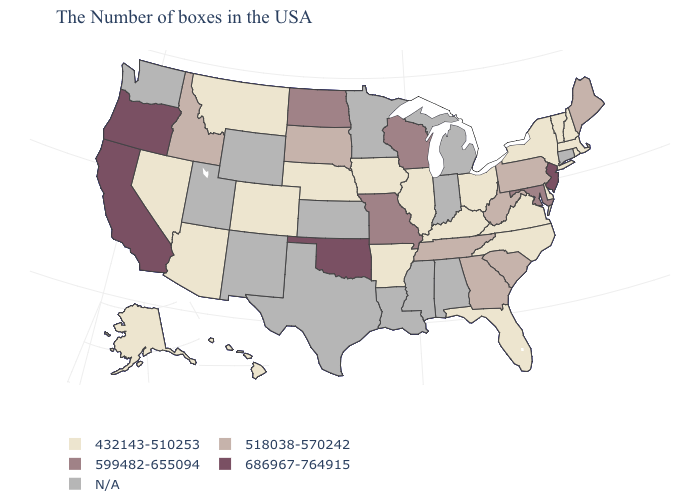What is the value of North Dakota?
Answer briefly. 599482-655094. Is the legend a continuous bar?
Write a very short answer. No. What is the lowest value in states that border South Dakota?
Concise answer only. 432143-510253. What is the value of Arkansas?
Quick response, please. 432143-510253. Name the states that have a value in the range N/A?
Be succinct. Connecticut, Michigan, Indiana, Alabama, Mississippi, Louisiana, Minnesota, Kansas, Texas, Wyoming, New Mexico, Utah, Washington. Does Maine have the lowest value in the Northeast?
Quick response, please. No. Among the states that border Louisiana , which have the highest value?
Concise answer only. Arkansas. Among the states that border Michigan , does Ohio have the highest value?
Quick response, please. No. Name the states that have a value in the range 432143-510253?
Short answer required. Massachusetts, Rhode Island, New Hampshire, Vermont, New York, Delaware, Virginia, North Carolina, Ohio, Florida, Kentucky, Illinois, Arkansas, Iowa, Nebraska, Colorado, Montana, Arizona, Nevada, Alaska, Hawaii. What is the lowest value in the USA?
Write a very short answer. 432143-510253. Among the states that border Idaho , which have the highest value?
Concise answer only. Oregon. Name the states that have a value in the range 599482-655094?
Give a very brief answer. Maryland, Wisconsin, Missouri, North Dakota. Name the states that have a value in the range 686967-764915?
Give a very brief answer. New Jersey, Oklahoma, California, Oregon. Name the states that have a value in the range 686967-764915?
Keep it brief. New Jersey, Oklahoma, California, Oregon. 